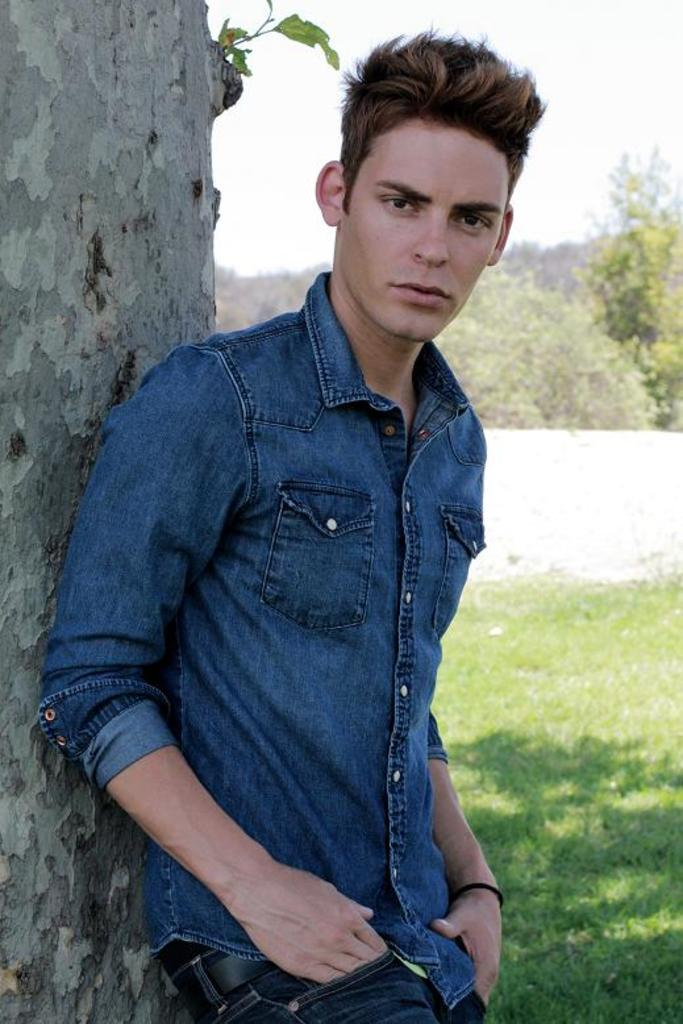What is the main subject in the foreground of the picture? There is a person in the foreground of the picture. What is the person doing in the image? The person is leaning on a tree trunk. What type of vegetation can be seen on the right side of the image? There is grass on the right side of the image. What can be seen in the background of the image? There are trees and the sky visible in the background of the image. What type of nail is the person using to climb the tree in the image? There is no nail present in the image, nor is the person climbing the tree. 